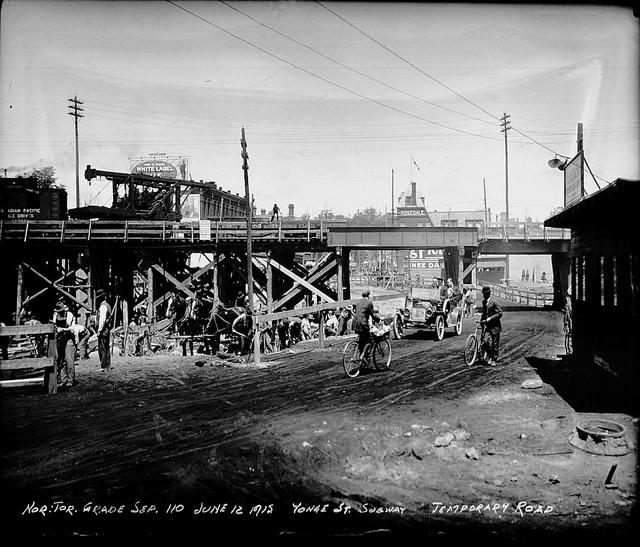What is near the car? Please explain your reasoning. bicycles. There are people pedaling these vehicles 